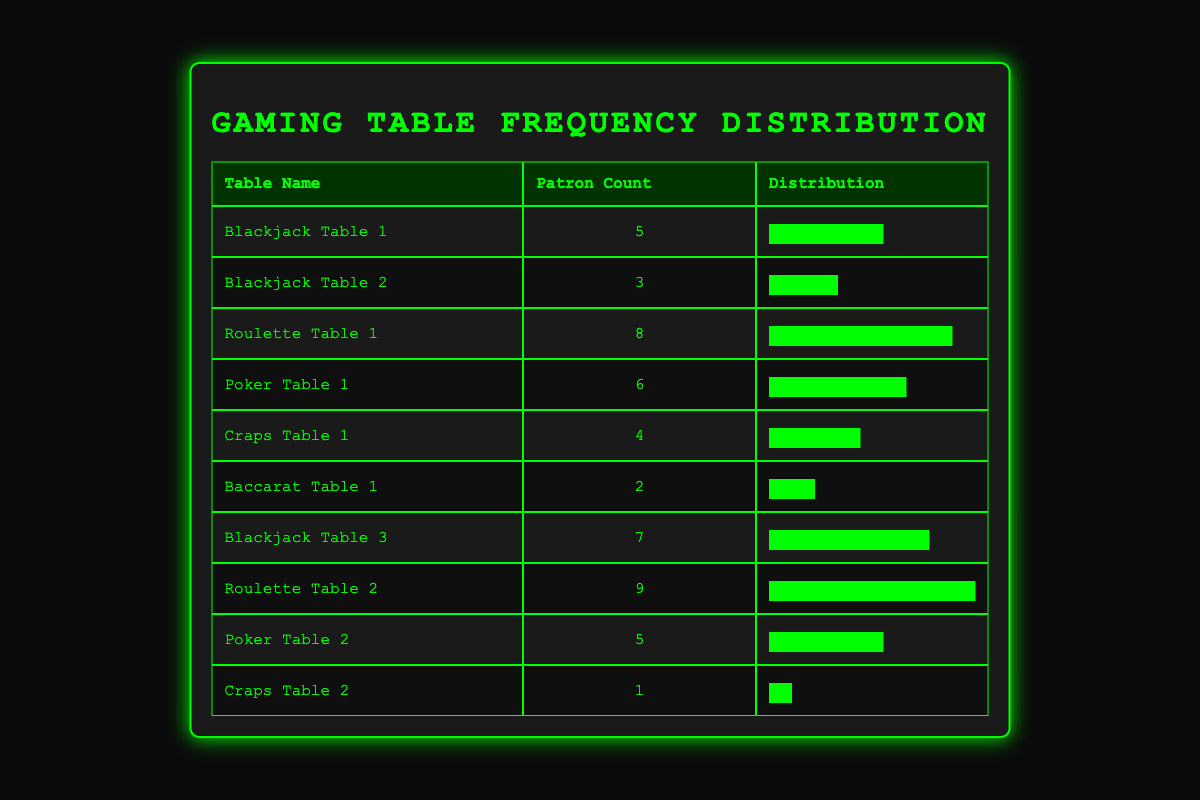What is the patron count at Roulette Table 2? The table lists Roulette Table 2 with a patron count of 9 under the "Patron Count" column.
Answer: 9 How many total patrons are at all the Blackjack tables combined? Summing the patron counts for all Blackjack tables: 5 (Table 1) + 3 (Table 2) + 7 (Table 3) = 15.
Answer: 15 Is there a Craps table with more than 1 patron? Looking at the patron counts for Craps Table 1 and Craps Table 2, Table 1 has 4 patrons and Table 2 has 1 patron. Since Table 1 has more than 1, the answer is yes.
Answer: Yes Which gaming table has the highest patron count and what is that count? The patron counts are compared, and Roulette Table 2 has the highest count with 9 patrons.
Answer: Roulette Table 2, 9 What is the average patron count across all tables? To find the average, sum all patron counts: 5 + 3 + 8 + 6 + 4 + 2 + 7 + 9 + 5 + 1 = 50. There are 10 tables, so the average is 50/10 = 5.
Answer: 5 Are there more Poker tables than Blackjack tables? There are 2 Poker tables (Poker Table 1 and Poker Table 2) and 3 Blackjack tables (Blackjack Table 1, 2, and 3). Since 3 is greater than 2, the answer is no.
Answer: No Which table has the second highest patron count, and what is that count? By comparing the patron counts, Roulette Table 1 has 8 patrons, which is the second highest after Roulette Table 2 with 9 patrons.
Answer: Roulette Table 1, 8 How many gaming tables have 5 or more patrons? The tables with 5 or more patrons are: Blackjack Table 1 (5), Poker Table 1 (6), Blackjack Table 3 (7), Roulette Table 1 (8), and Roulette Table 2 (9). This counts to 5 tables.
Answer: 5 